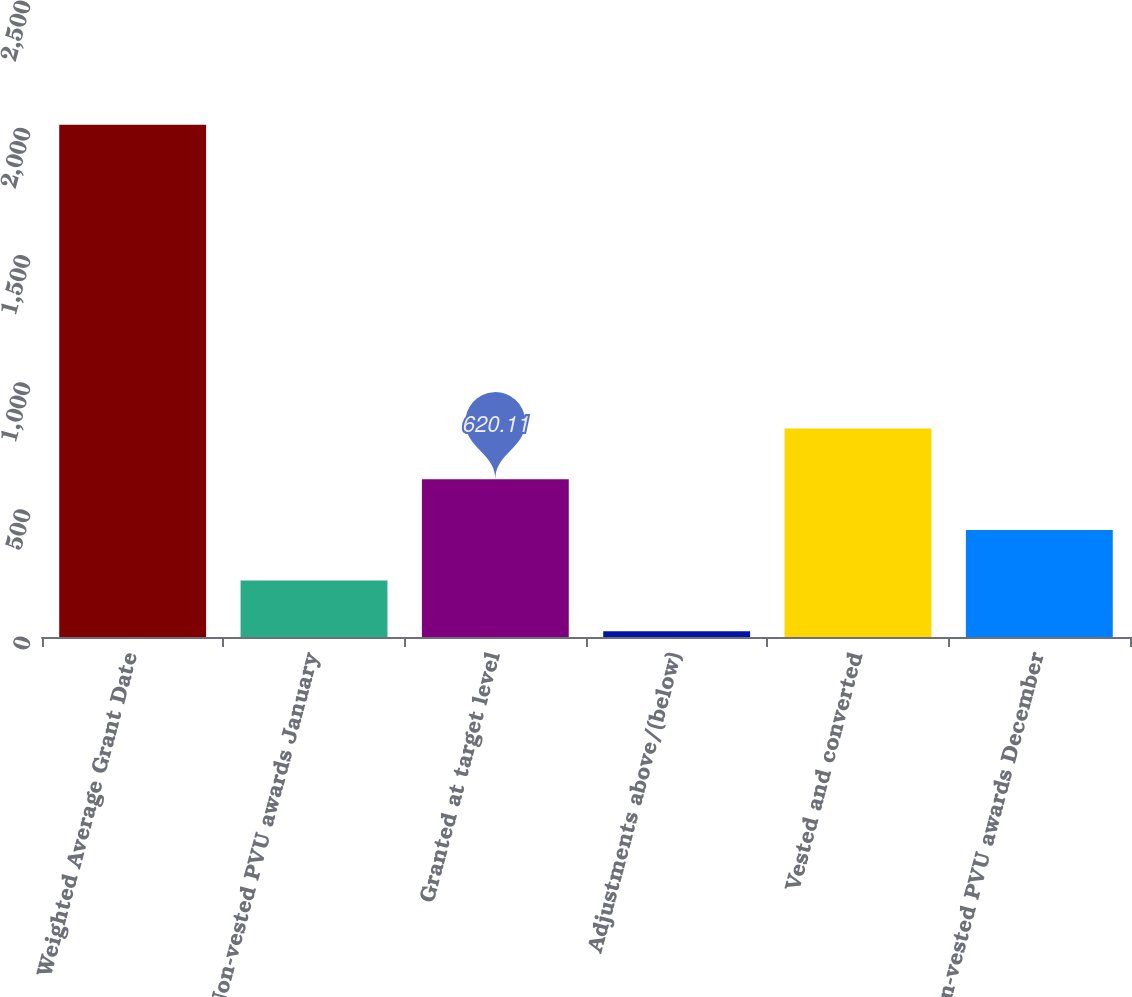Convert chart. <chart><loc_0><loc_0><loc_500><loc_500><bar_chart><fcel>Weighted Average Grant Date<fcel>Non-vested PVU awards January<fcel>Granted at target level<fcel>Adjustments above/(below)<fcel>Vested and converted<fcel>Non-vested PVU awards December<nl><fcel>2014<fcel>221.85<fcel>620.11<fcel>22.72<fcel>819.24<fcel>420.98<nl></chart> 